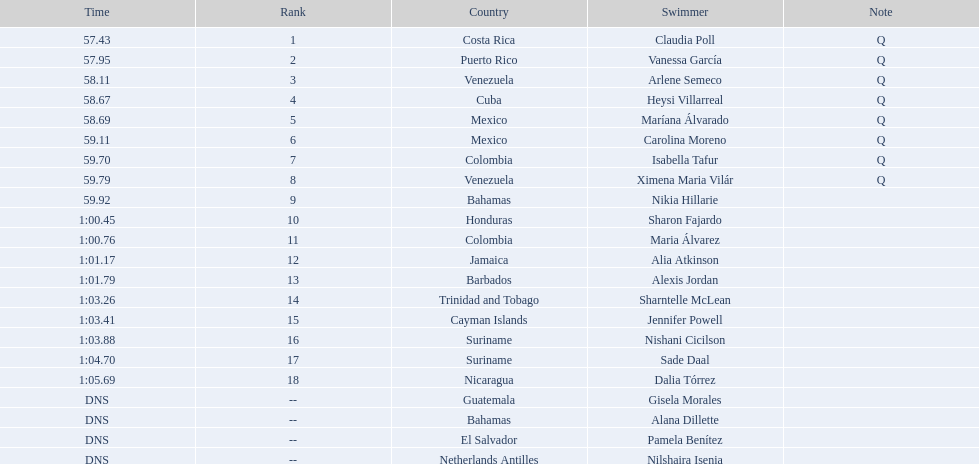Who was the finisher right behind claudia poll? Vanessa García. 